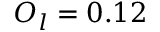Convert formula to latex. <formula><loc_0><loc_0><loc_500><loc_500>O _ { l } = 0 . 1 2</formula> 